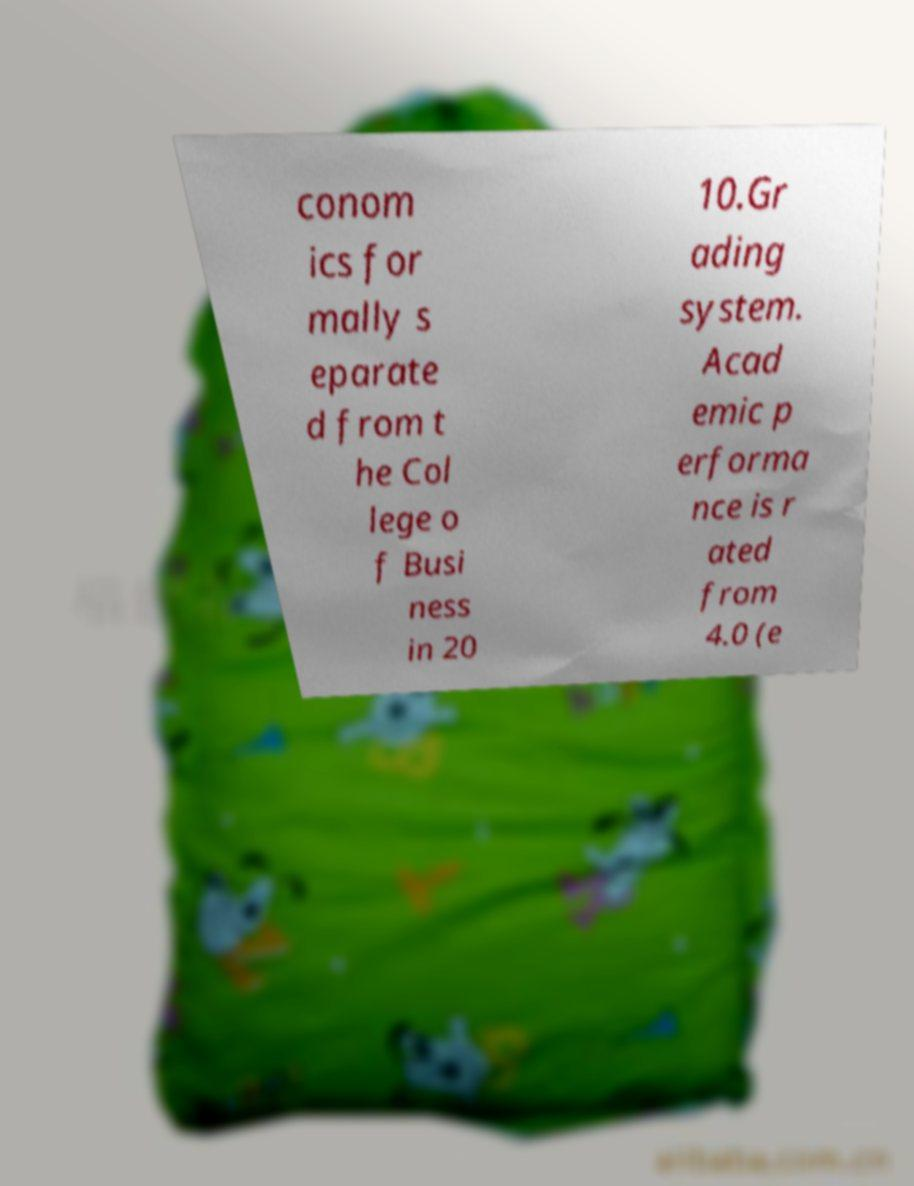There's text embedded in this image that I need extracted. Can you transcribe it verbatim? conom ics for mally s eparate d from t he Col lege o f Busi ness in 20 10.Gr ading system. Acad emic p erforma nce is r ated from 4.0 (e 